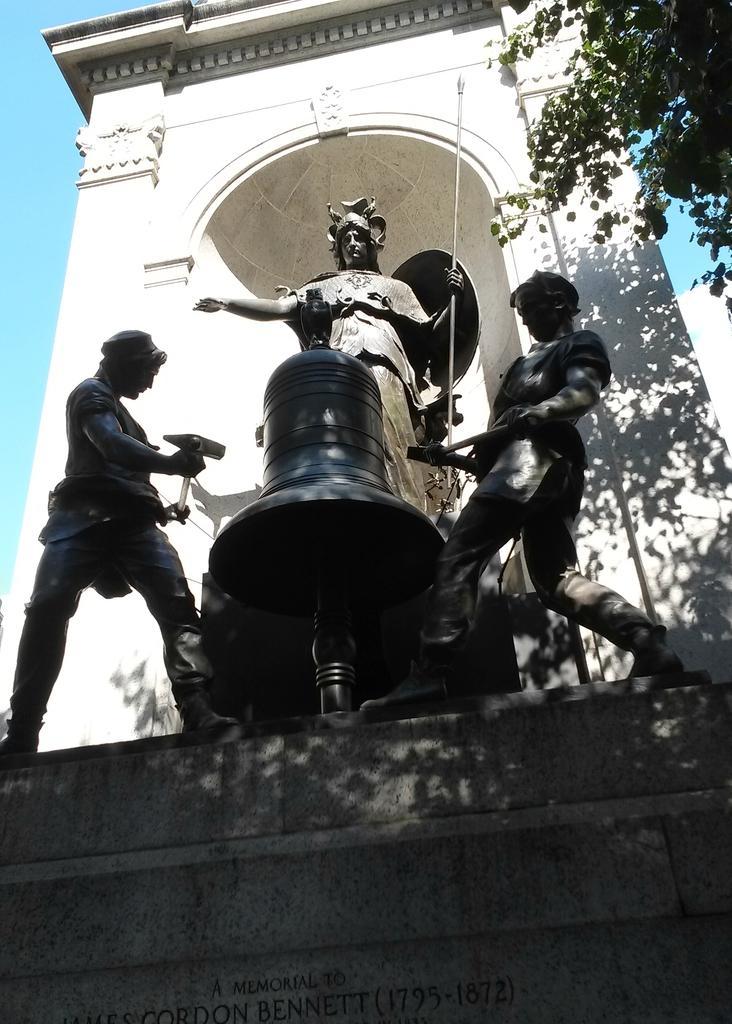Describe this image in one or two sentences. In this image we can see statues. Here we have three statues and one bell like structure statue. Trees are there and a text was written on the wall. 